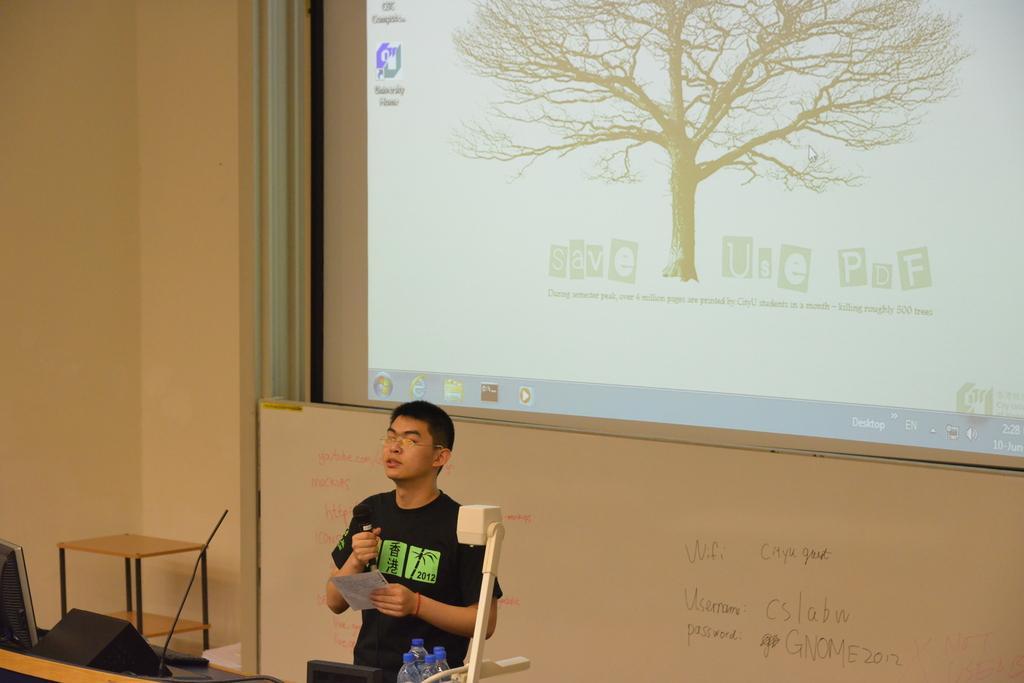Could you give a brief overview of what you see in this image? The image is inside the room. In the image there is a man standing and holding a microphone and paper on other hand. On right side we can see water bottle and left side there is a table, on table there is a keyboard,monitor and speakers in background there is a screen and board on which it is written something. 